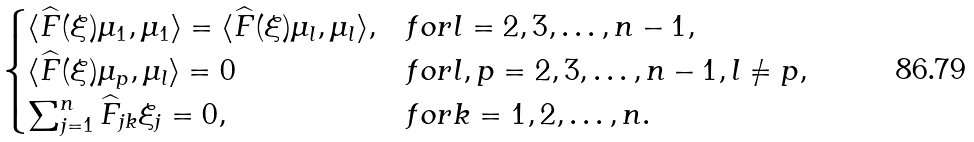<formula> <loc_0><loc_0><loc_500><loc_500>\begin{cases} \langle \widehat { F } ( \xi ) \mu _ { 1 } , \mu _ { 1 } \rangle = \langle \widehat { F } ( \xi ) \mu _ { l } , \mu _ { l } \rangle , & f o r l = 2 , 3 , \dots , n - 1 , \\ \langle \widehat { F } ( \xi ) \mu _ { p } , \mu _ { l } \rangle = 0 & f o r l , p = 2 , 3 , \dots , n - 1 , l \neq p , \\ \sum _ { j = 1 } ^ { n } \widehat { F } _ { j k } \xi _ { j } = 0 , & f o r k = 1 , 2 , \dots , n . \end{cases}</formula> 